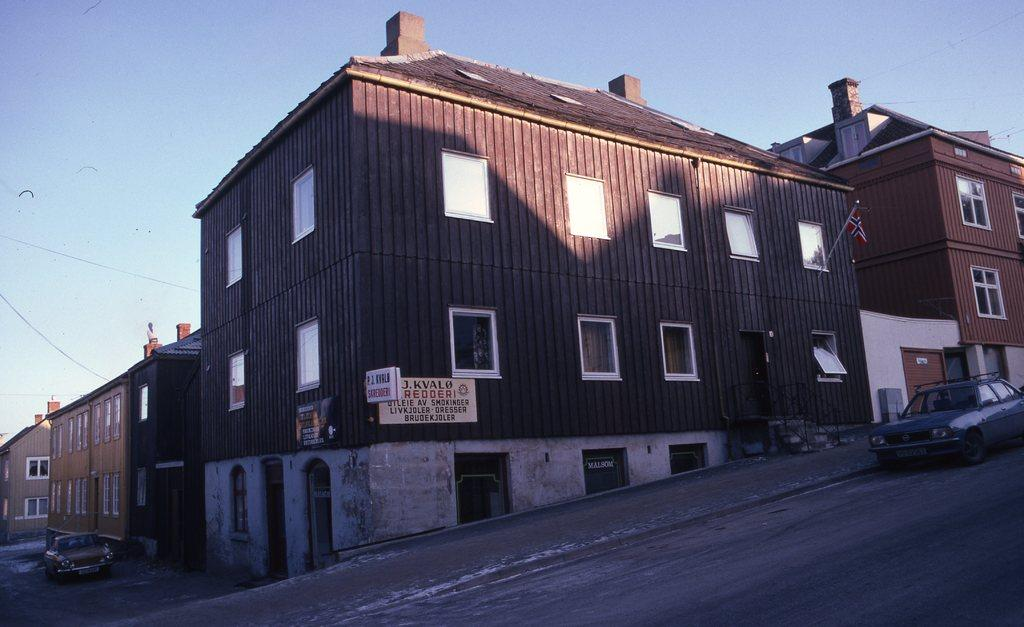What type of structures can be seen in the image? There are buildings in the image. What type of vehicles are present in the image? There are cars in the image. What architectural feature can be seen on the buildings? There are windows in the image. What type of signage is present in the image? There are banners in the image. What is visible at the top of the image? The sky is visible at the top of the image. Can you tell me the rate at which the plane is flying in the image? There is no plane present in the image, so it is not possible to determine the rate at which it might be flying. Where is the throne located in the image? There is no throne present in the image. 